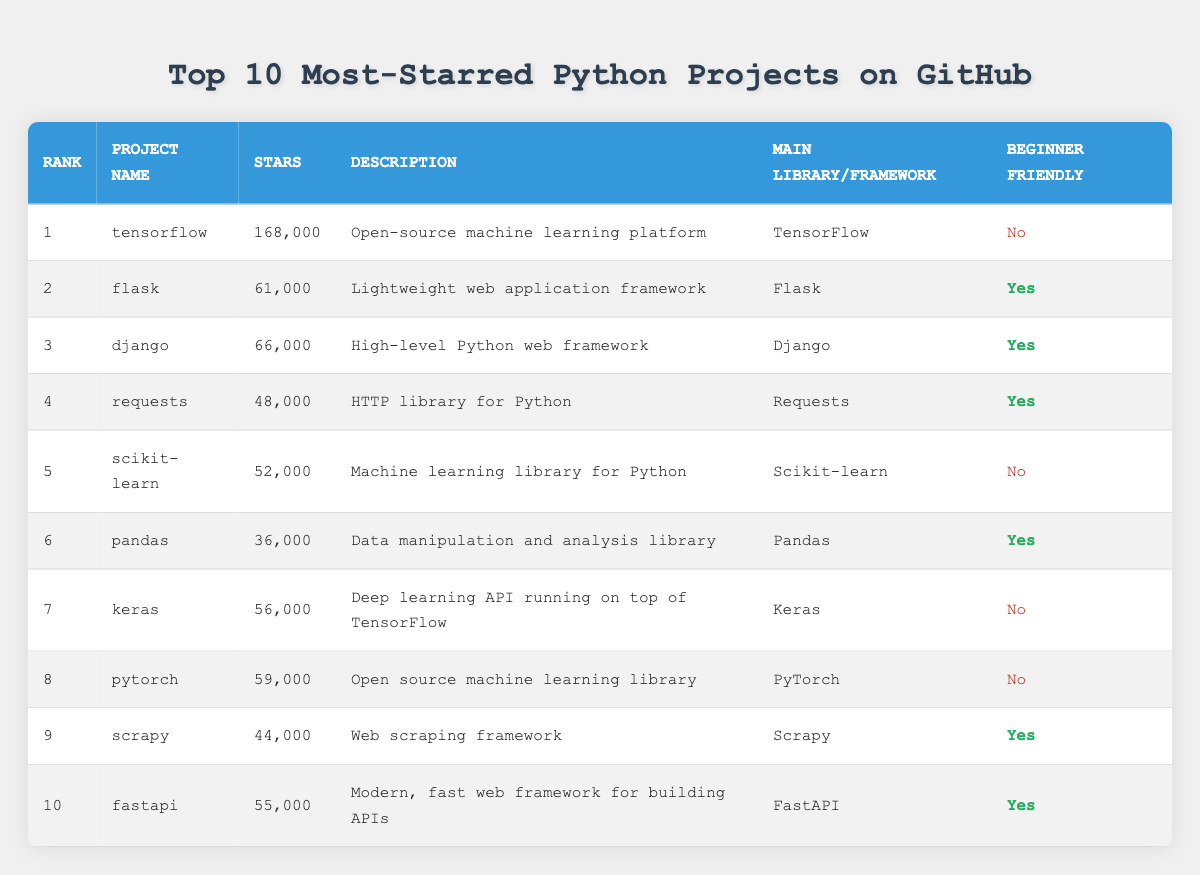What project has the highest number of stars? The table shows that "tensorflow" has 168,000 stars, which is the highest among all the projects listed.
Answer: tensorflow How many projects have more than 50,000 stars? By examining the stars column, we can see that four projects (tensorflow, flask, django, and keras) have more than 50,000 stars. Therefore, the count is 4.
Answer: 4 Is "fastapi" considered beginner friendly? The table indicates that "fastapi" is marked as "Yes" under the "Beginner Friendly" column, which means it is considered beginner friendly.
Answer: Yes What is the total number of stars for all projects labeled as beginner friendly? Looking at the relevant rows for beginner friendly projects: flask (61,000), django (66,000), requests (48,000), pandas (36,000), scrapy (44,000), and fastapi (55,000), we sum these values: 61,000 + 66,000 + 48,000 + 36,000 + 44,000 + 55,000 = 310,000. Therefore, the total is 310,000.
Answer: 310000 Which project has the lowest number of stars among beginner friendly projects? Examining the beginner friendly projects, we find: flask (61,000), django (66,000), requests (48,000), pandas (36,000), scrapy (44,000), and fastapi (55,000). The project with the lowest stars is "pandas" with 36,000 stars.
Answer: pandas How many projects are not beginner friendly? From the table, there are 4 projects marked as "No" under the "Beginner Friendly" column: tensorflow, scikit-learn, keras, and pytorch. Thus, the number of non-beginner friendly projects is 4.
Answer: 4 Which project is a web framework and has more stars than "requests"? By examining rows for web frameworks: flask (61,000) and django (66,000) both have more stars than requests (48,000). Hence, both flask and django qualify.
Answer: flask, django Is "pytorch" the only machine learning library that is not beginner friendly? The table lists scikit-learn along with pytorch as not beginner friendly machine learning libraries. Therefore, "pytorch" is not the only one; there is also scikit-learn.
Answer: No 